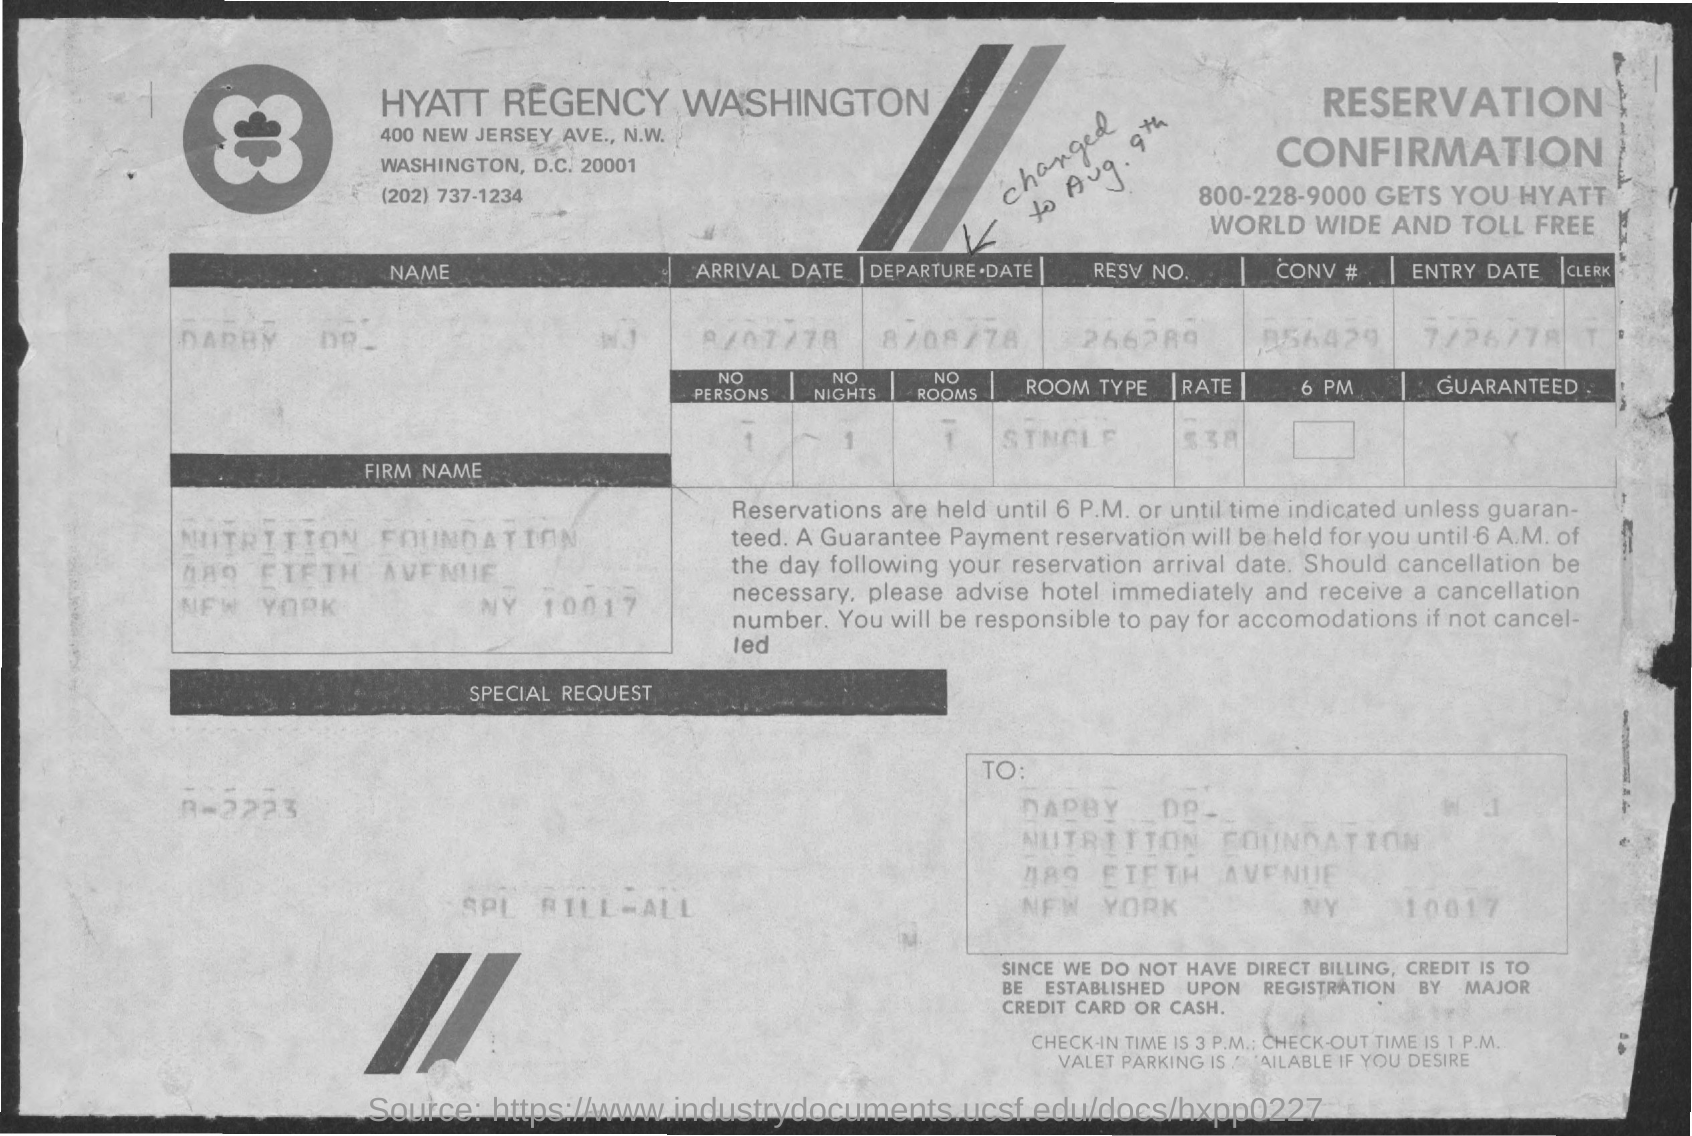Is there any information about payment or billing? Yes, the document states 'SINCE WE DO NOT HAVE DIRECT BILLING, CREDIT IS TO BE ESTABLISHED UPON REGISTRATION BY MAJOR CREDIT CARD OR CASH.' This suggests that the guest needs to provide a credit card or cash at the time of registration to cover the costs of the stay. What are the check-in and check-out times mentioned? According to the document, the check-in time is 3 P.M., and the check-out time is 1 P.M. 